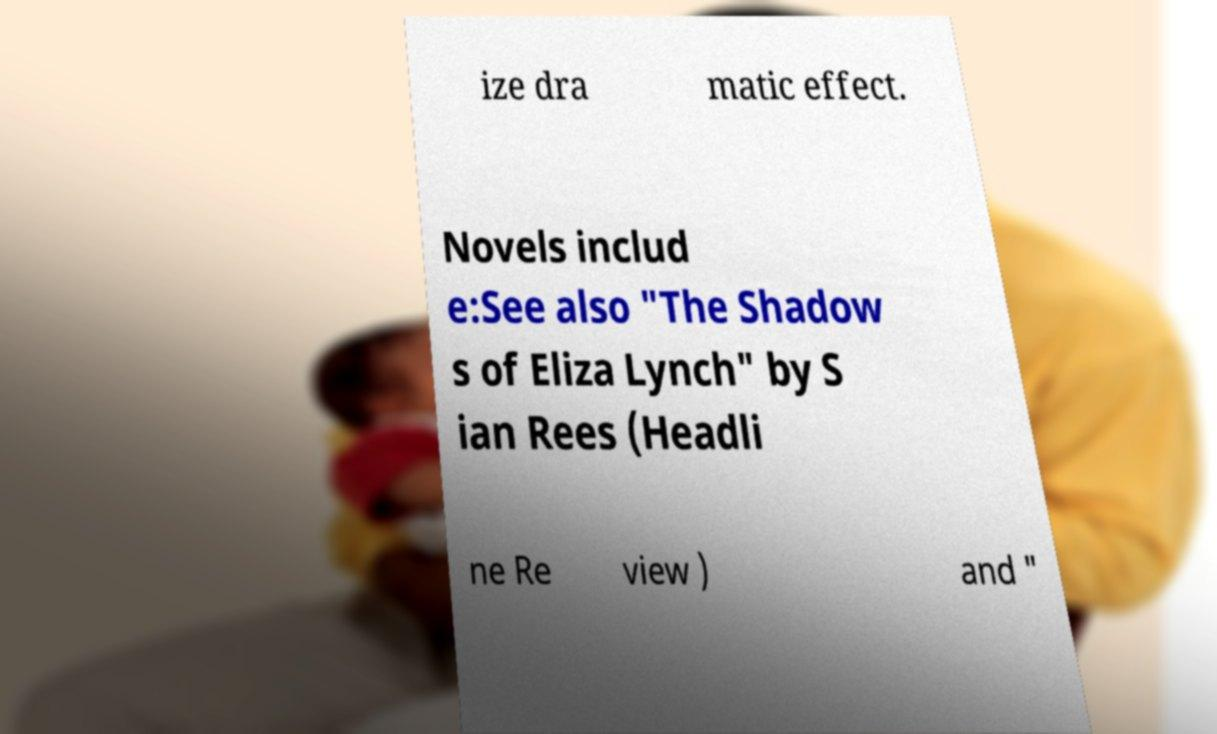There's text embedded in this image that I need extracted. Can you transcribe it verbatim? ize dra matic effect. Novels includ e:See also "The Shadow s of Eliza Lynch" by S ian Rees (Headli ne Re view ) and " 